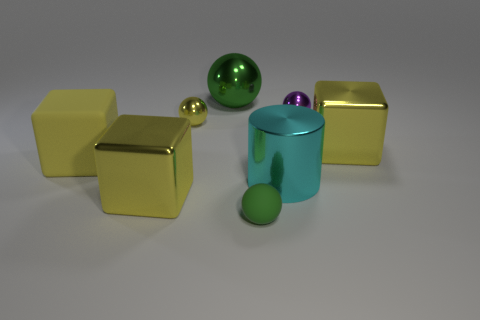Can you tell me what the overall color scheme of the objects in the image suggests? The color scheme of the objects, featuring metallic yellow, shiny green, and purple, suggests a visually stimulating contrast. Yellow grabs attention, green adds a sense of vitality, and purple introduces an element of luxury or creativity. 